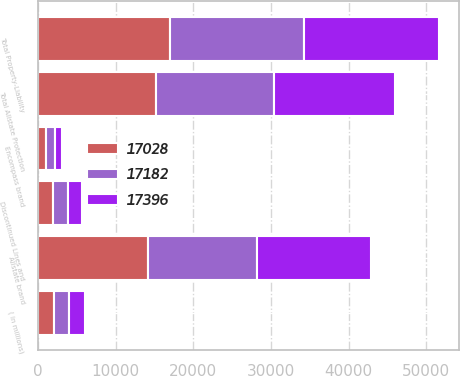<chart> <loc_0><loc_0><loc_500><loc_500><stacked_bar_chart><ecel><fcel>( in millions)<fcel>Allstate brand<fcel>Encompass brand<fcel>Total Allstate Protection<fcel>Discontinued Lines and<fcel>Total Property-Liability<nl><fcel>17396<fcel>2010<fcel>14696<fcel>921<fcel>15617<fcel>1779<fcel>17396<nl><fcel>17028<fcel>2009<fcel>14123<fcel>1027<fcel>15150<fcel>1878<fcel>17028<nl><fcel>17182<fcel>2008<fcel>14118<fcel>1133<fcel>15251<fcel>1931<fcel>17182<nl></chart> 